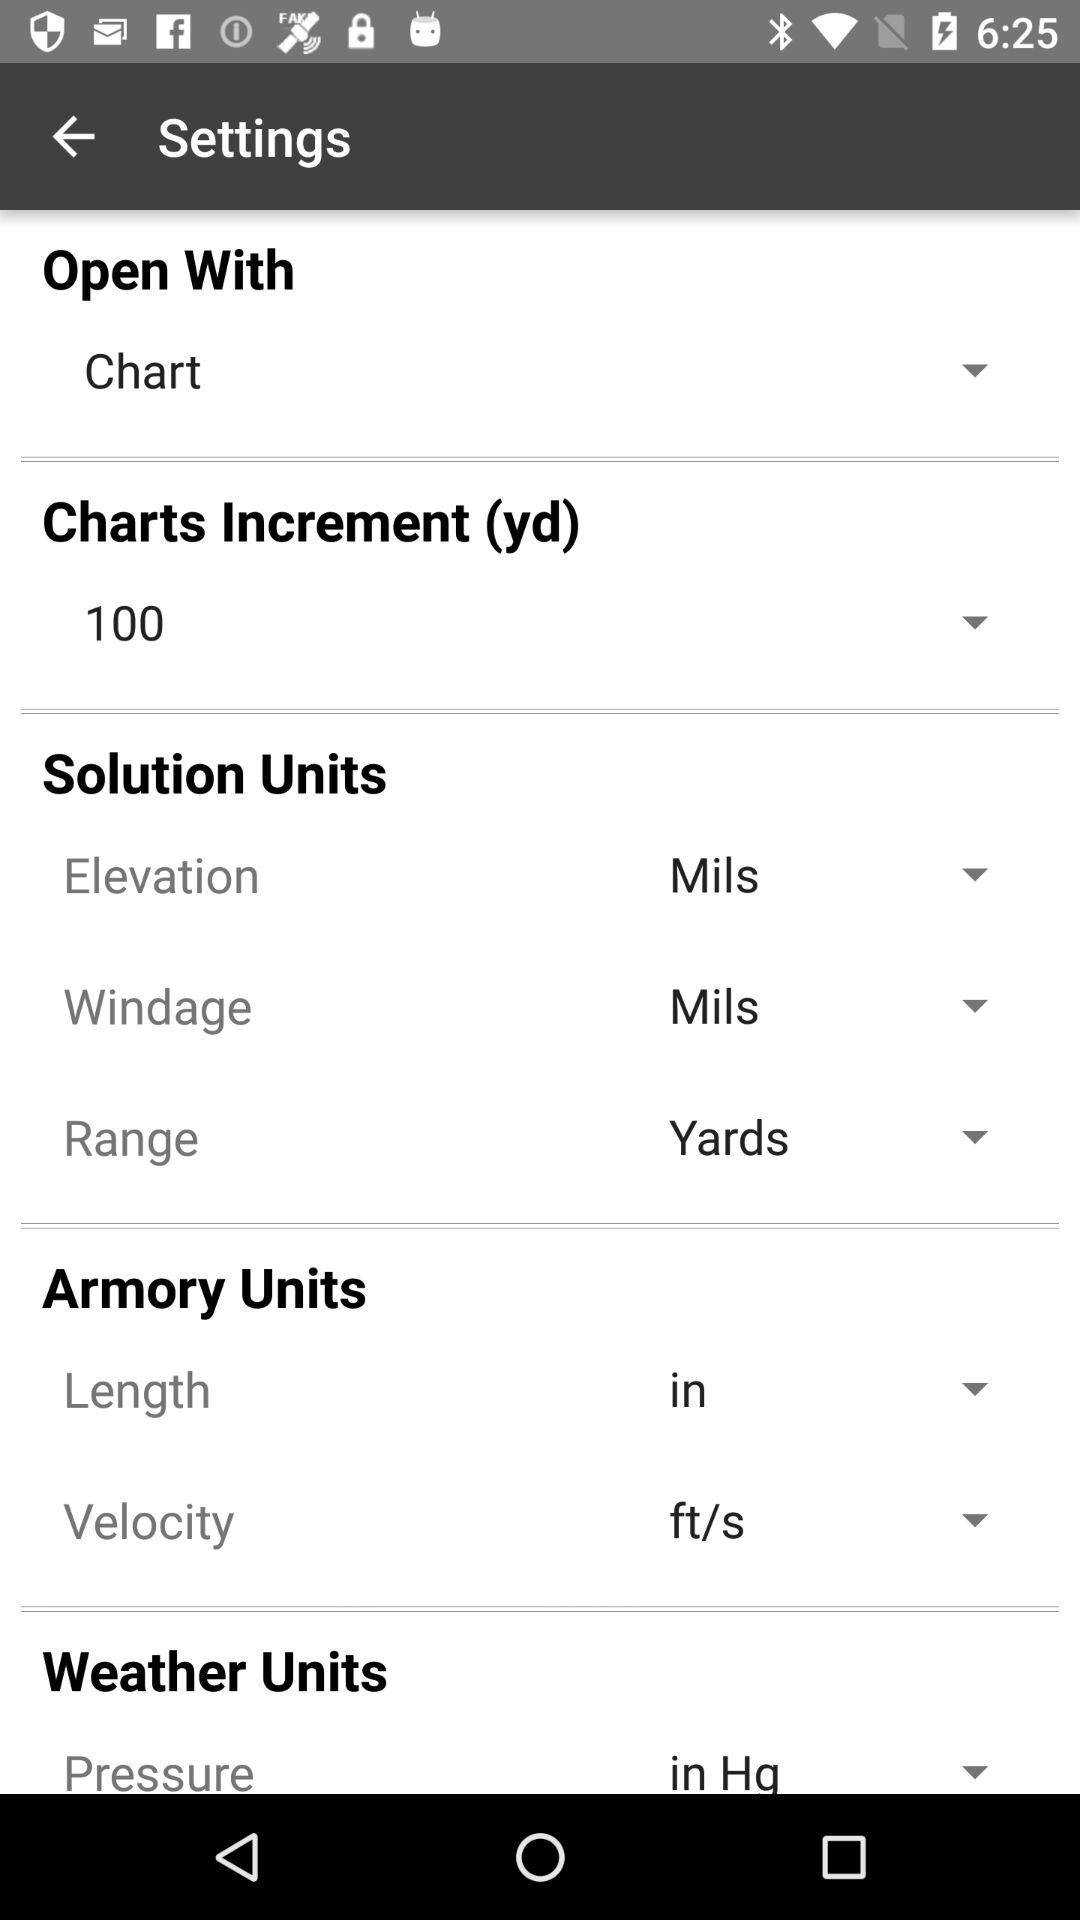What is the unit for pressure is selected? The selected unit for pressure is "in Hg". 